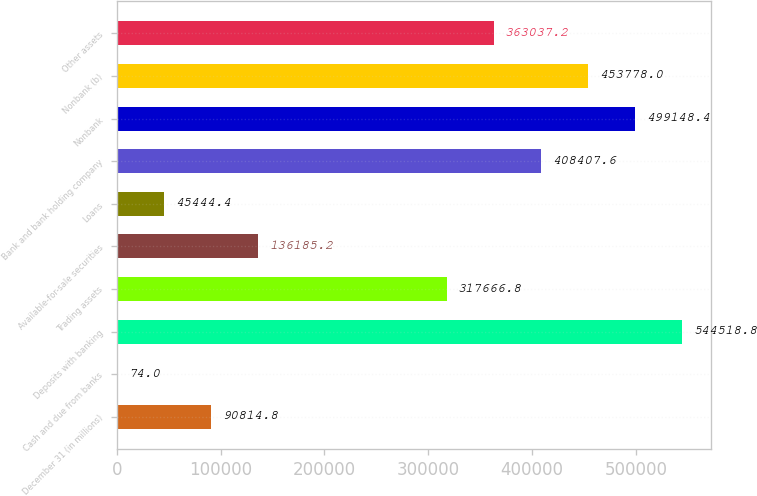<chart> <loc_0><loc_0><loc_500><loc_500><bar_chart><fcel>December 31 (in millions)<fcel>Cash and due from banks<fcel>Deposits with banking<fcel>Trading assets<fcel>Available-for-sale securities<fcel>Loans<fcel>Bank and bank holding company<fcel>Nonbank<fcel>Nonbank (b)<fcel>Other assets<nl><fcel>90814.8<fcel>74<fcel>544519<fcel>317667<fcel>136185<fcel>45444.4<fcel>408408<fcel>499148<fcel>453778<fcel>363037<nl></chart> 